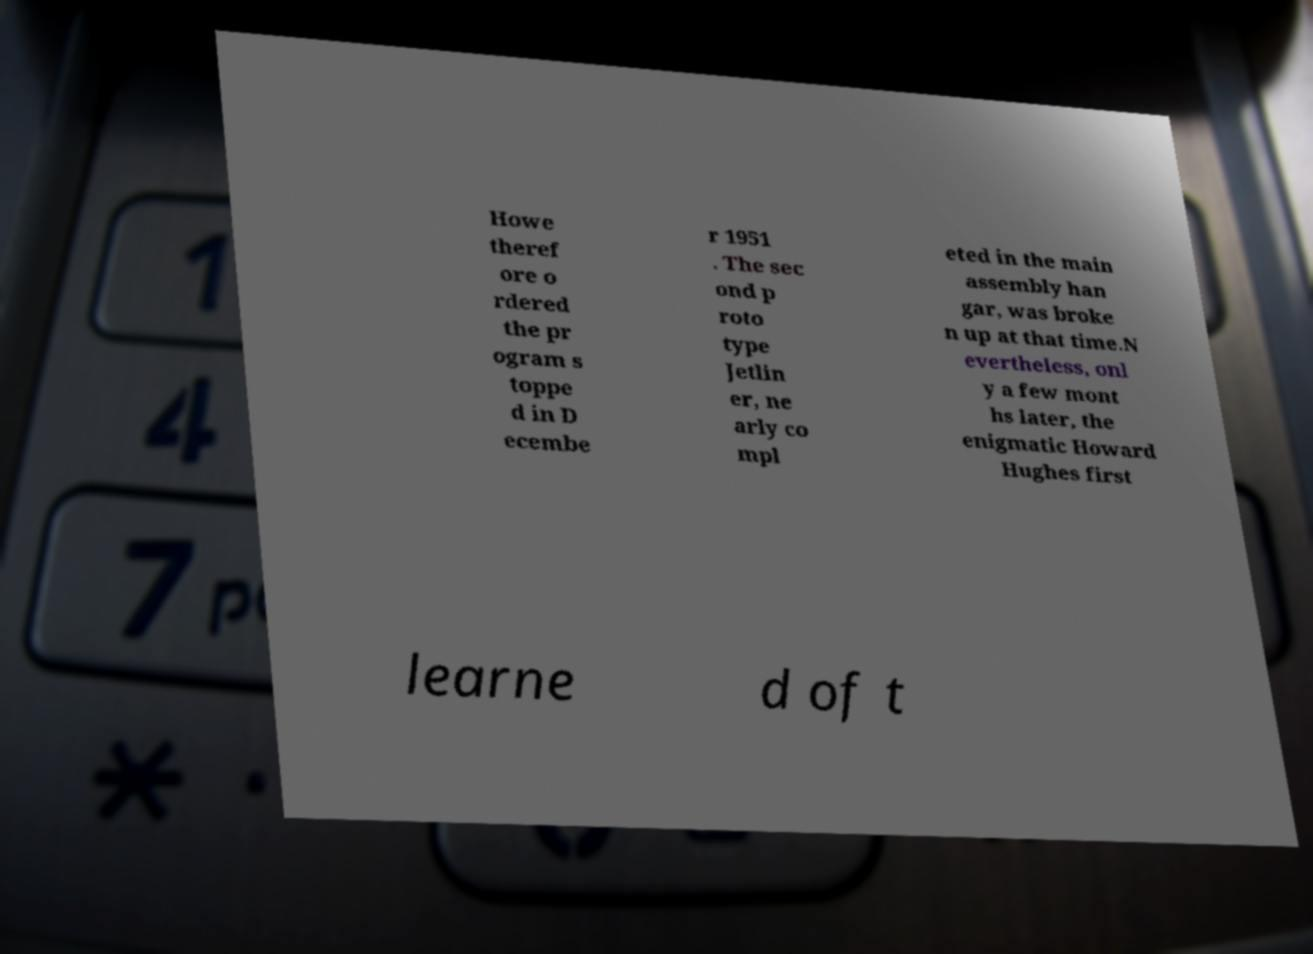Can you accurately transcribe the text from the provided image for me? Howe theref ore o rdered the pr ogram s toppe d in D ecembe r 1951 . The sec ond p roto type Jetlin er, ne arly co mpl eted in the main assembly han gar, was broke n up at that time.N evertheless, onl y a few mont hs later, the enigmatic Howard Hughes first learne d of t 